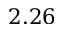<formula> <loc_0><loc_0><loc_500><loc_500>2 . 2 6</formula> 